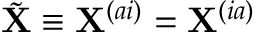<formula> <loc_0><loc_0><loc_500><loc_500>\tilde { X } \equiv X ^ { ( a i ) } = X ^ { ( i a ) }</formula> 